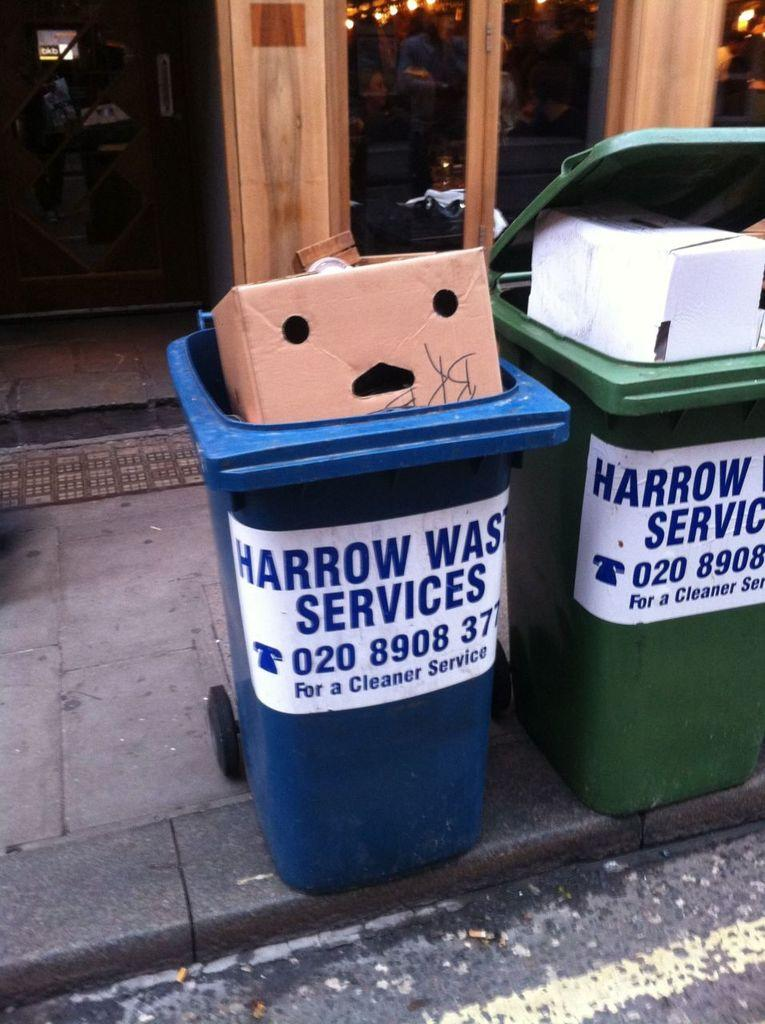<image>
Provide a brief description of the given image. Two harrow waste services full of trash and boxes 